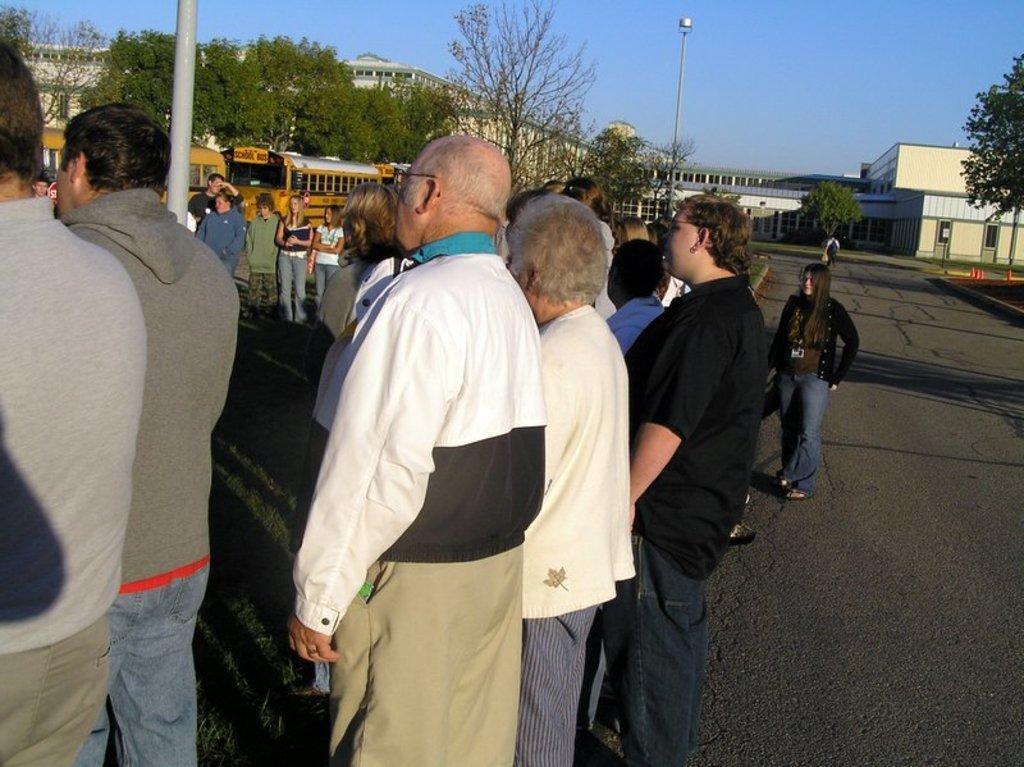Describe this image in one or two sentences. In this image there are people standing near a pole on a road, in the background there are trees, buses, buildings and sky. 